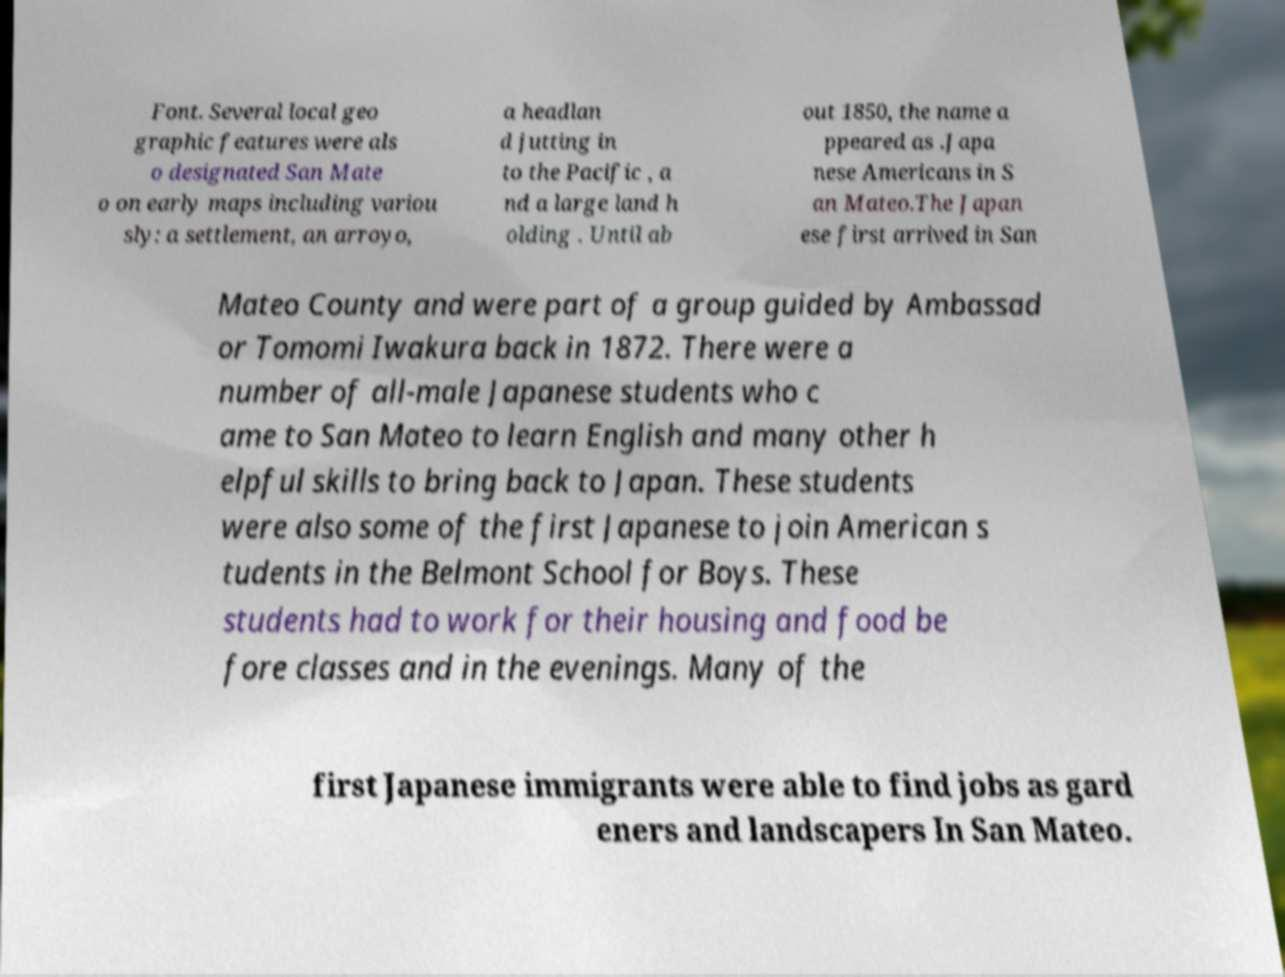There's text embedded in this image that I need extracted. Can you transcribe it verbatim? Font. Several local geo graphic features were als o designated San Mate o on early maps including variou sly: a settlement, an arroyo, a headlan d jutting in to the Pacific , a nd a large land h olding . Until ab out 1850, the name a ppeared as .Japa nese Americans in S an Mateo.The Japan ese first arrived in San Mateo County and were part of a group guided by Ambassad or Tomomi Iwakura back in 1872. There were a number of all-male Japanese students who c ame to San Mateo to learn English and many other h elpful skills to bring back to Japan. These students were also some of the first Japanese to join American s tudents in the Belmont School for Boys. These students had to work for their housing and food be fore classes and in the evenings. Many of the first Japanese immigrants were able to find jobs as gard eners and landscapers In San Mateo. 